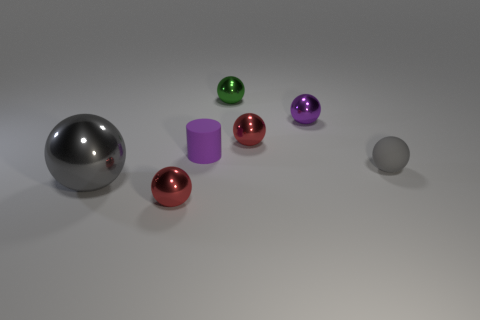Subtract all gray metal balls. How many balls are left? 5 Add 1 tiny spheres. How many objects exist? 8 Subtract all spheres. How many objects are left? 1 Subtract all gray balls. How many balls are left? 4 Subtract 0 cyan blocks. How many objects are left? 7 Subtract 6 balls. How many balls are left? 0 Subtract all brown cylinders. Subtract all blue balls. How many cylinders are left? 1 Subtract all brown cubes. How many blue cylinders are left? 0 Subtract all green balls. Subtract all tiny matte balls. How many objects are left? 5 Add 5 gray matte objects. How many gray matte objects are left? 6 